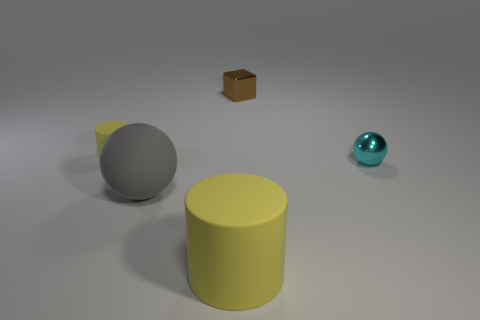Add 3 small cyan things. How many objects exist? 8 Subtract all balls. How many objects are left? 3 Add 2 big yellow rubber cylinders. How many big yellow rubber cylinders exist? 3 Subtract 0 red balls. How many objects are left? 5 Subtract all brown balls. Subtract all yellow cubes. How many balls are left? 2 Subtract all shiny cylinders. Subtract all small rubber objects. How many objects are left? 4 Add 5 gray rubber spheres. How many gray rubber spheres are left? 6 